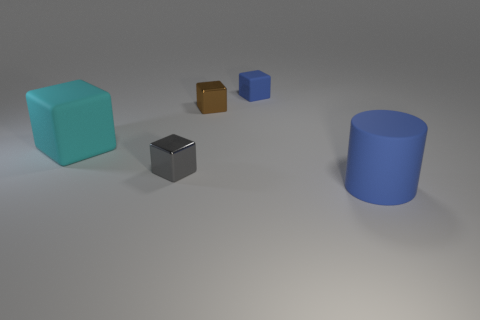Subtract all large blocks. How many blocks are left? 3 Add 4 metal things. How many objects exist? 9 Subtract all gray blocks. How many blocks are left? 3 Subtract all cylinders. How many objects are left? 4 Add 4 small blue rubber things. How many small blue rubber things are left? 5 Add 3 brown blocks. How many brown blocks exist? 4 Subtract 0 green blocks. How many objects are left? 5 Subtract 2 blocks. How many blocks are left? 2 Subtract all cyan cylinders. Subtract all purple blocks. How many cylinders are left? 1 Subtract all cyan balls. How many red cylinders are left? 0 